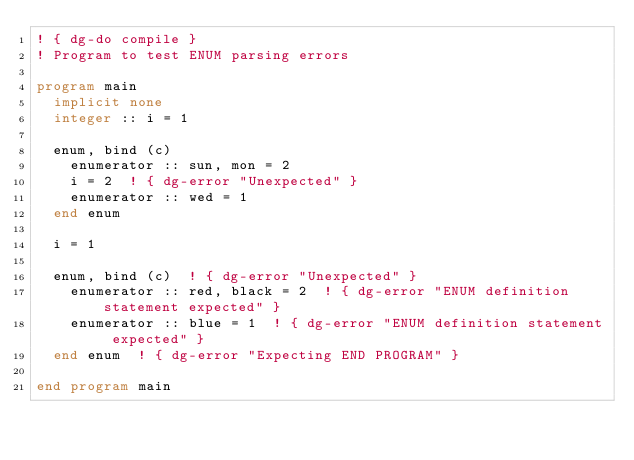<code> <loc_0><loc_0><loc_500><loc_500><_FORTRAN_>! { dg-do compile }
! Program to test ENUM parsing errors 

program main
  implicit none
  integer :: i = 1

  enum, bind (c)
    enumerator :: sun, mon = 2    
    i = 2  ! { dg-error "Unexpected" }  
    enumerator :: wed = 1    
  end enum       

  i = 1

  enum, bind (c)  ! { dg-error "Unexpected" } 
    enumerator :: red, black = 2  ! { dg-error "ENUM definition statement expected" }
    enumerator :: blue = 1  ! { dg-error "ENUM definition statement expected" }
  end enum  ! { dg-error "Expecting END PROGRAM" }

end program main        
</code> 